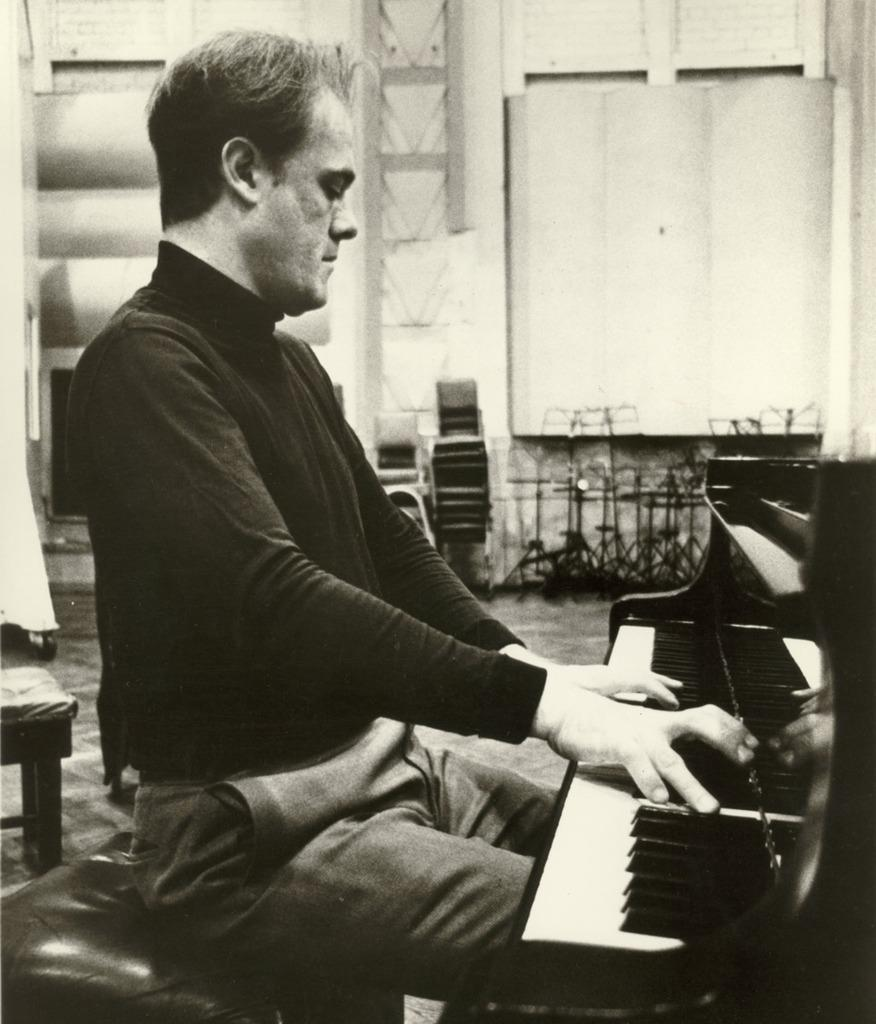What is the man in the image doing? The man is playing a keyboard. What is the man wearing in the image? The man is wearing a black t-shirt and trousers. What can be seen in the background of the image? There is a stool, chairs, and a wall in the background of the image. Where are the scissors located in the image? There are no scissors present in the image. What type of fan is being used by the man in the image? There is no fan present in the image; the man is playing a keyboard. 